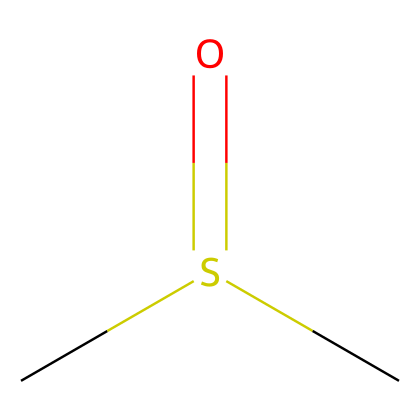What is the chemical name of this compound? The SMILES representation indicates that the compound consists of a carbon atom (C), a sulfur atom (S), and a double-bonded oxygen (O) on a sulfur atom. Thus, the chemical name is dimethyl sulfoxide.
Answer: dimethyl sulfoxide How many carbon atoms are in this molecule? By analyzing the SMILES notation, the "C" at the beginning represents one carbon atom, and the "C" indicating the second carbon atom attached to the sulfur. Therefore, there are two carbon atoms.
Answer: two What functional group is present in this compound? The structure includes a sulfur atom bonded to a carbon with a double-bonded oxygen, indicating the presence of a sulfoxide functional group.
Answer: sulfoxide What is the total number of atoms in this molecule? Counting the atoms from the SMILES representation, there are two carbon atoms, one sulfur atom, and one oxygen atom, giving a total of four atoms in the molecule.
Answer: four How many bonds are formed by the sulfur atom? The sulfur atom is bonded to two carbon atoms (two single bonds) and one oxygen atom (one double bond), totaling three bonds.
Answer: three Is this compound polar or nonpolar? The presence of the highly electronegative oxygen and the asymmetrical structure (due to the sulfoxide group) suggests that the molecule is polar.
Answer: polar 